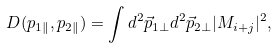<formula> <loc_0><loc_0><loc_500><loc_500>D ( p _ { 1 \| } , p _ { 2 \| } ) = \int d ^ { 2 } \vec { p } _ { 1 \perp } d ^ { 2 } \vec { p } _ { 2 \bot } | M _ { i + j } | ^ { 2 } ,</formula> 